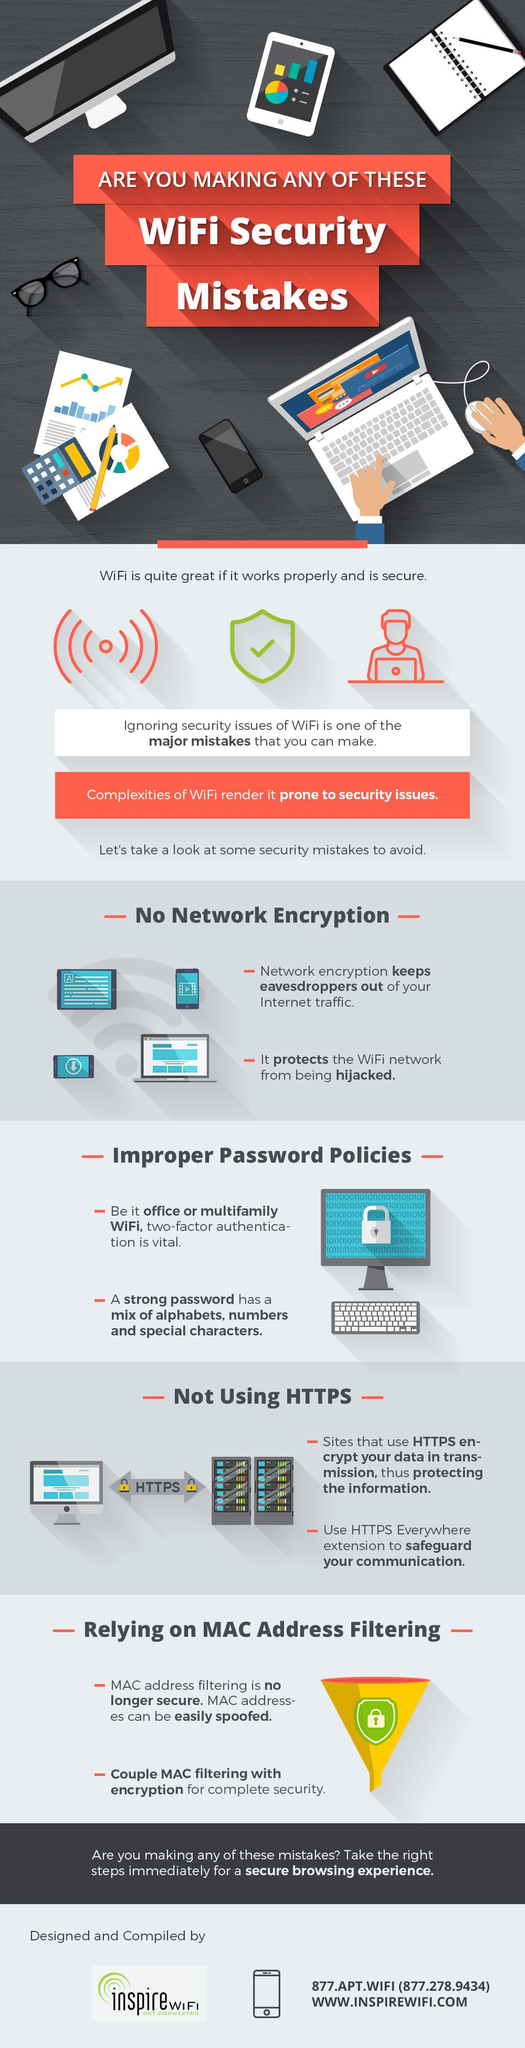Indicate a few pertinent items in this graphic. The color of the lock on either side of HTTPS is yellow. Network encryption is essential to prevent eavesdropping and hijacking. The color of the funnel is yellow. In addition to special characters and a mix of letters, a strong password also requires the use of numbers. 